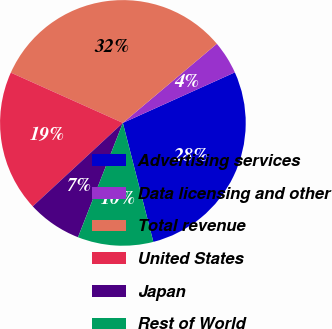Convert chart to OTSL. <chart><loc_0><loc_0><loc_500><loc_500><pie_chart><fcel>Advertising services<fcel>Data licensing and other<fcel>Total revenue<fcel>United States<fcel>Japan<fcel>Rest of World<nl><fcel>27.76%<fcel>4.39%<fcel>32.15%<fcel>18.6%<fcel>7.16%<fcel>9.94%<nl></chart> 